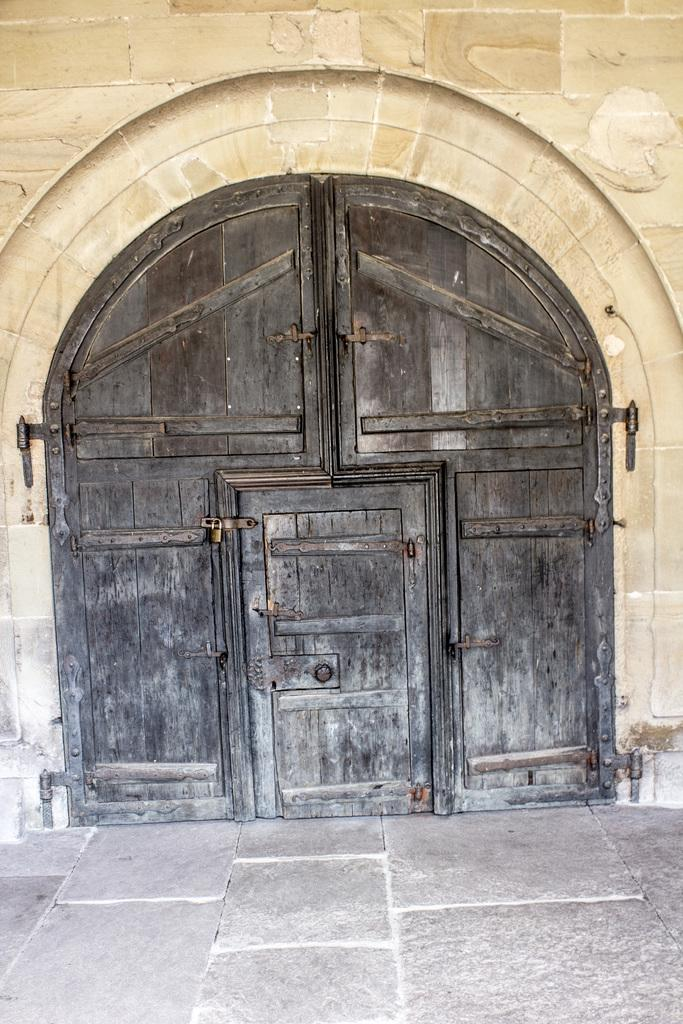What is located in the center of the image? There is a door in the center of the image. What is above the door in the image? There is a wall on top of the door in the image. How many bears are visible in the image? There are no bears present in the image. What type of event is taking place in the image? There is no event taking place in the image; it simply shows a door with a wall above it. 